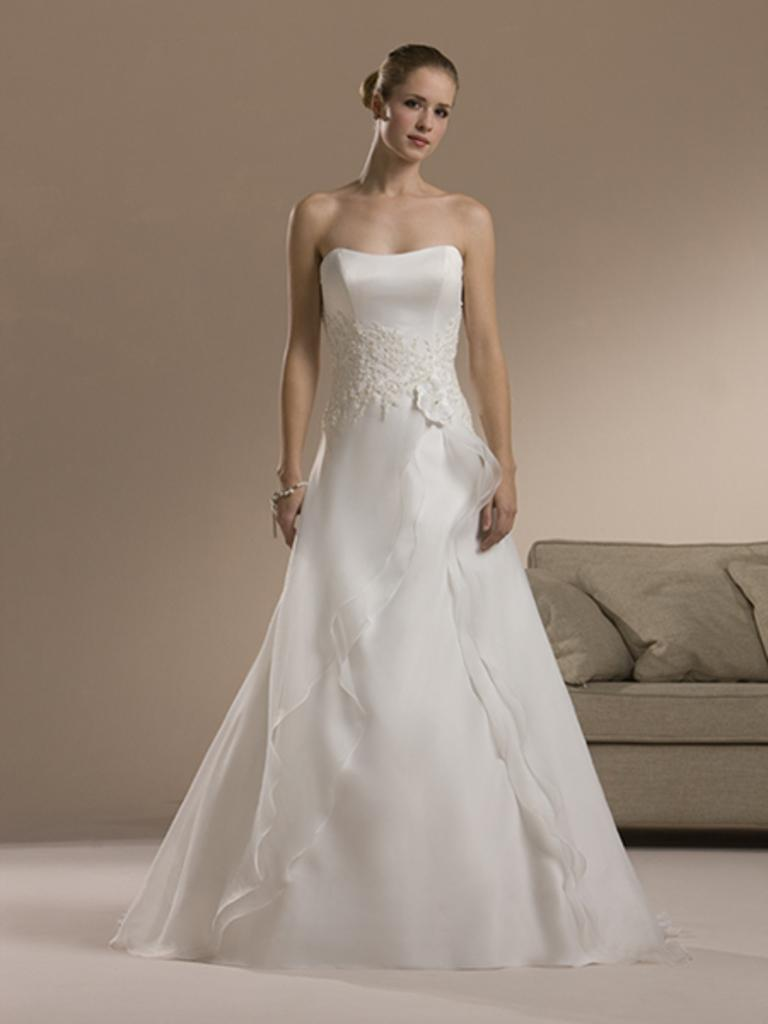Who is present in the image? There is a woman in the image. What is the woman doing in the image? The woman is standing on the floor. What is the woman wearing in the image? The woman is wearing a white dress. What can be seen in the background of the image? A: There are pillows on a sofa and a wall visible in the background of the image. How many bird nests are visible in the image? There are no bird nests visible in the image. 